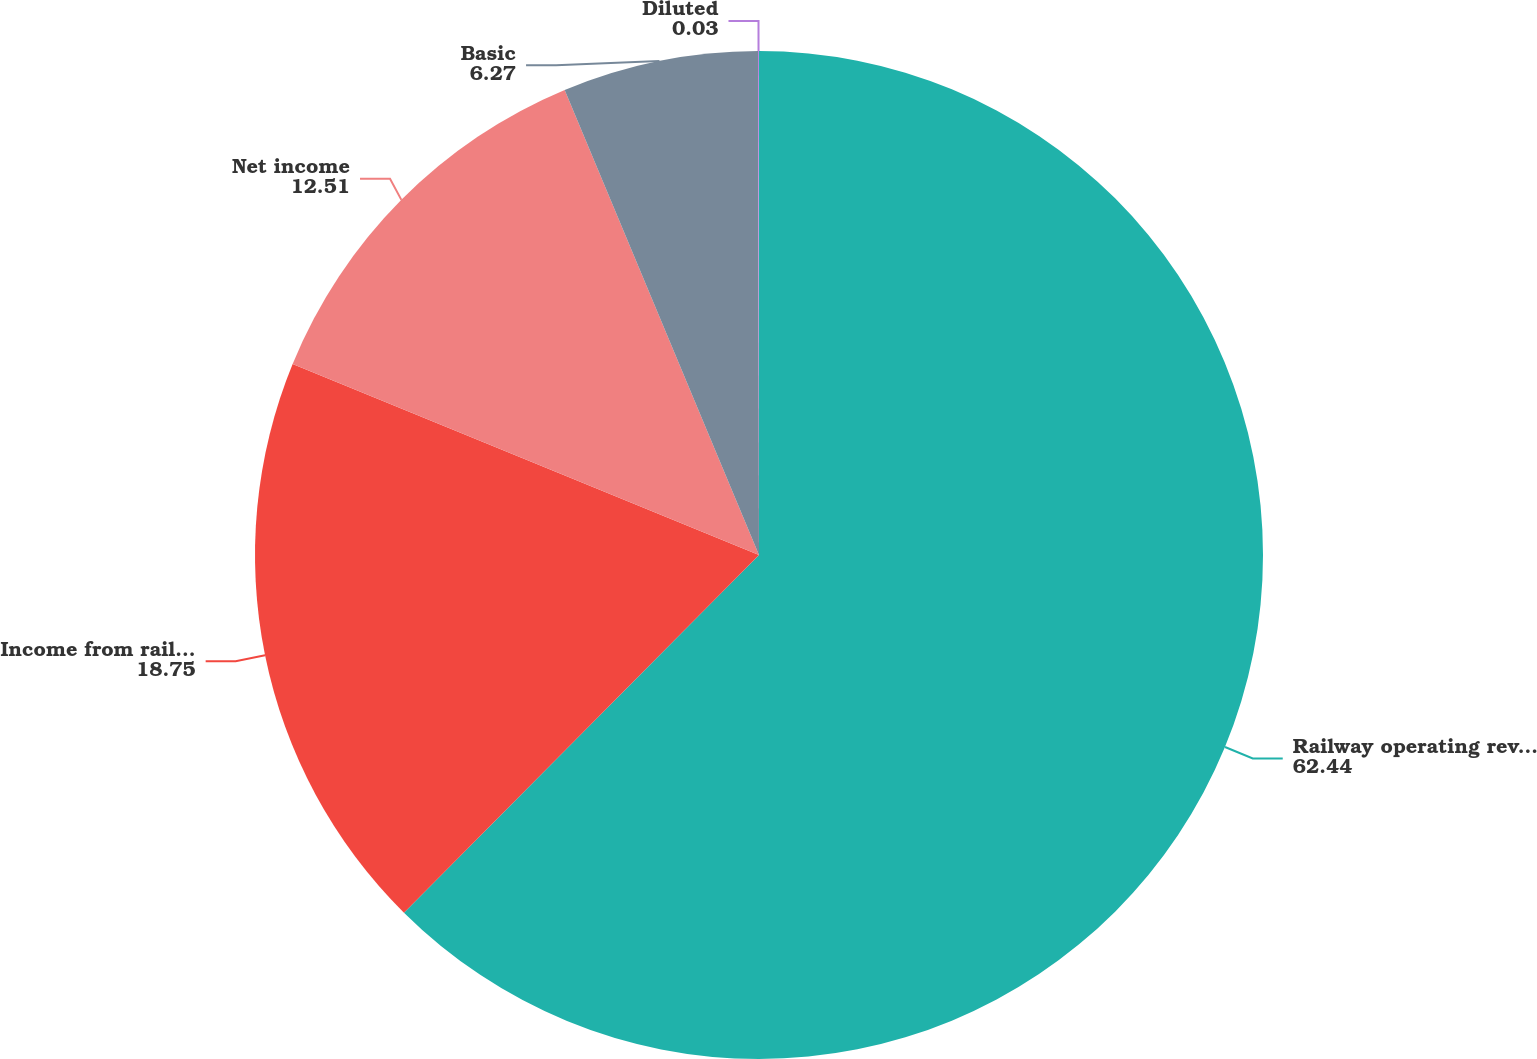Convert chart to OTSL. <chart><loc_0><loc_0><loc_500><loc_500><pie_chart><fcel>Railway operating revenues<fcel>Income from railway operations<fcel>Net income<fcel>Basic<fcel>Diluted<nl><fcel>62.44%<fcel>18.75%<fcel>12.51%<fcel>6.27%<fcel>0.03%<nl></chart> 